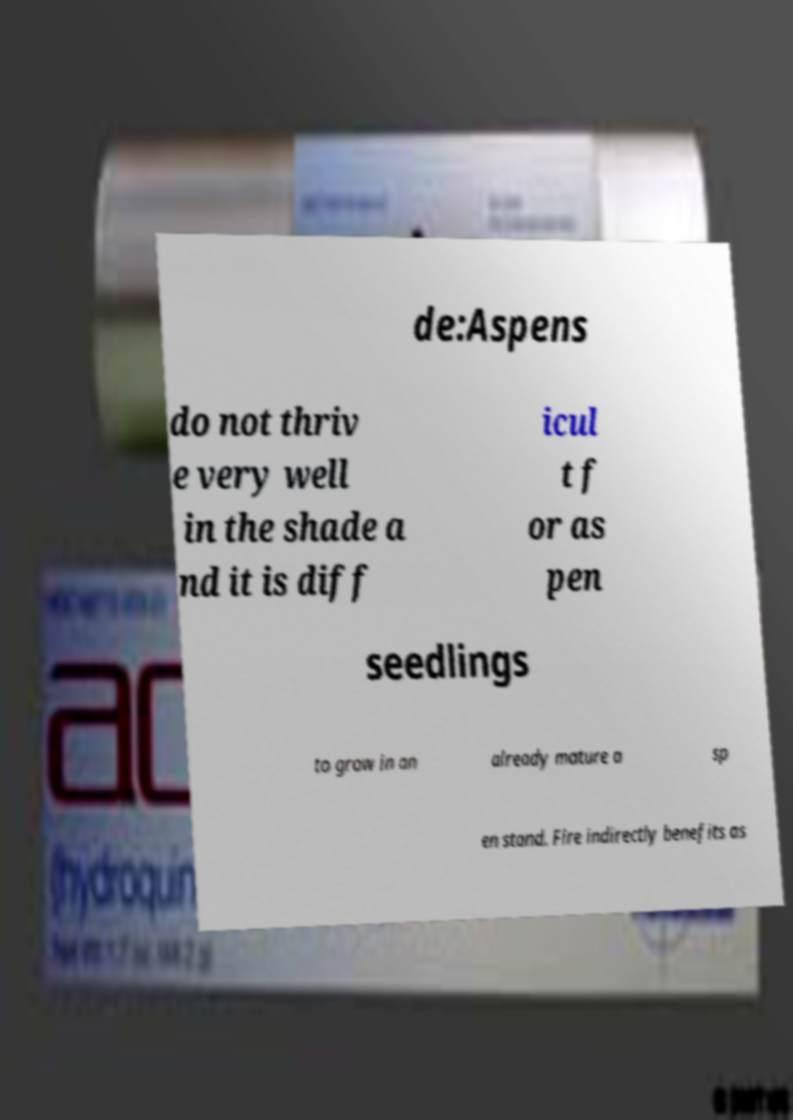I need the written content from this picture converted into text. Can you do that? de:Aspens do not thriv e very well in the shade a nd it is diff icul t f or as pen seedlings to grow in an already mature a sp en stand. Fire indirectly benefits as 